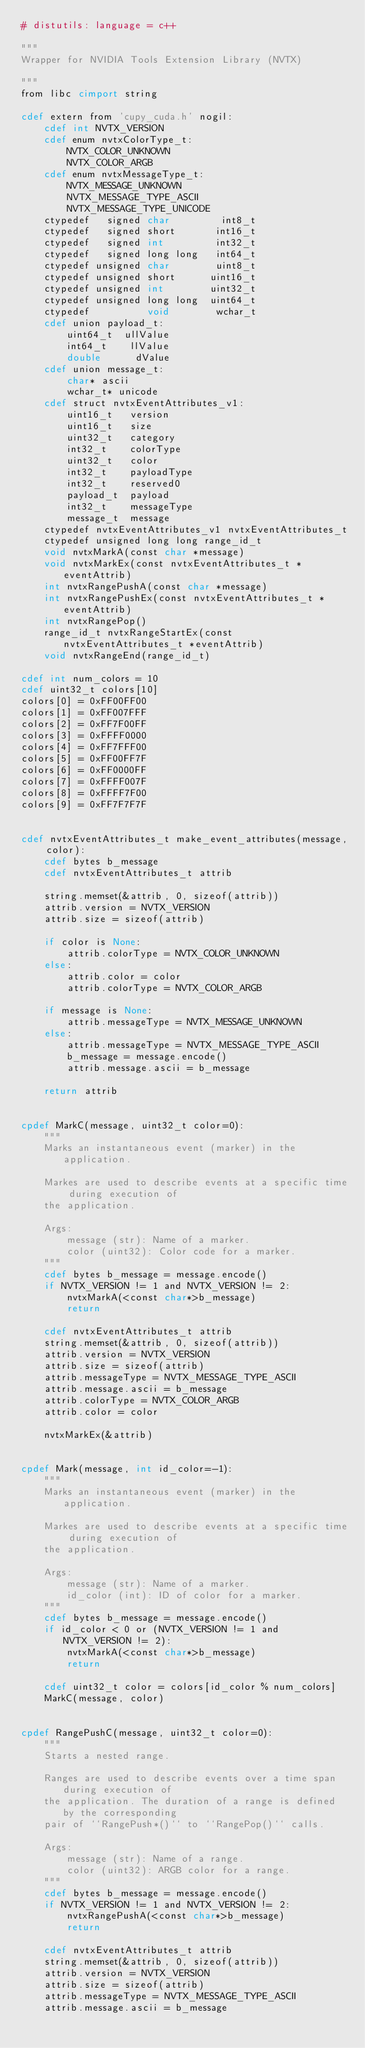<code> <loc_0><loc_0><loc_500><loc_500><_Cython_># distutils: language = c++

"""
Wrapper for NVIDIA Tools Extension Library (NVTX)

"""
from libc cimport string

cdef extern from 'cupy_cuda.h' nogil:
    cdef int NVTX_VERSION
    cdef enum nvtxColorType_t:
        NVTX_COLOR_UNKNOWN
        NVTX_COLOR_ARGB
    cdef enum nvtxMessageType_t:
        NVTX_MESSAGE_UNKNOWN
        NVTX_MESSAGE_TYPE_ASCII
        NVTX_MESSAGE_TYPE_UNICODE
    ctypedef   signed char         int8_t
    ctypedef   signed short       int16_t
    ctypedef   signed int         int32_t
    ctypedef   signed long long   int64_t
    ctypedef unsigned char        uint8_t
    ctypedef unsigned short      uint16_t
    ctypedef unsigned int        uint32_t
    ctypedef unsigned long long  uint64_t
    ctypedef          void        wchar_t
    cdef union payload_t:
        uint64_t  ullValue
        int64_t    llValue
        double      dValue
    cdef union message_t:
        char* ascii
        wchar_t* unicode
    cdef struct nvtxEventAttributes_v1:
        uint16_t   version
        uint16_t   size
        uint32_t   category
        int32_t    colorType
        uint32_t   color
        int32_t    payloadType
        int32_t    reserved0
        payload_t  payload
        int32_t    messageType
        message_t  message
    ctypedef nvtxEventAttributes_v1 nvtxEventAttributes_t
    ctypedef unsigned long long range_id_t
    void nvtxMarkA(const char *message)
    void nvtxMarkEx(const nvtxEventAttributes_t *eventAttrib)
    int nvtxRangePushA(const char *message)
    int nvtxRangePushEx(const nvtxEventAttributes_t *eventAttrib)
    int nvtxRangePop()
    range_id_t nvtxRangeStartEx(const nvtxEventAttributes_t *eventAttrib)
    void nvtxRangeEnd(range_id_t)

cdef int num_colors = 10
cdef uint32_t colors[10]
colors[0] = 0xFF00FF00
colors[1] = 0xFF007FFF
colors[2] = 0xFF7F00FF
colors[3] = 0xFFFF0000
colors[4] = 0xFF7FFF00
colors[5] = 0xFF00FF7F
colors[6] = 0xFF0000FF
colors[7] = 0xFFFF007F
colors[8] = 0xFFFF7F00
colors[9] = 0xFF7F7F7F


cdef nvtxEventAttributes_t make_event_attributes(message, color):
    cdef bytes b_message
    cdef nvtxEventAttributes_t attrib

    string.memset(&attrib, 0, sizeof(attrib))
    attrib.version = NVTX_VERSION
    attrib.size = sizeof(attrib)

    if color is None:
        attrib.colorType = NVTX_COLOR_UNKNOWN
    else:
        attrib.color = color
        attrib.colorType = NVTX_COLOR_ARGB

    if message is None:
        attrib.messageType = NVTX_MESSAGE_UNKNOWN
    else:
        attrib.messageType = NVTX_MESSAGE_TYPE_ASCII
        b_message = message.encode()
        attrib.message.ascii = b_message

    return attrib


cpdef MarkC(message, uint32_t color=0):
    """
    Marks an instantaneous event (marker) in the application.

    Markes are used to describe events at a specific time during execution of
    the application.

    Args:
        message (str): Name of a marker.
        color (uint32): Color code for a marker.
    """
    cdef bytes b_message = message.encode()
    if NVTX_VERSION != 1 and NVTX_VERSION != 2:
        nvtxMarkA(<const char*>b_message)
        return

    cdef nvtxEventAttributes_t attrib
    string.memset(&attrib, 0, sizeof(attrib))
    attrib.version = NVTX_VERSION
    attrib.size = sizeof(attrib)
    attrib.messageType = NVTX_MESSAGE_TYPE_ASCII
    attrib.message.ascii = b_message
    attrib.colorType = NVTX_COLOR_ARGB
    attrib.color = color

    nvtxMarkEx(&attrib)


cpdef Mark(message, int id_color=-1):
    """
    Marks an instantaneous event (marker) in the application.

    Markes are used to describe events at a specific time during execution of
    the application.

    Args:
        message (str): Name of a marker.
        id_color (int): ID of color for a marker.
    """
    cdef bytes b_message = message.encode()
    if id_color < 0 or (NVTX_VERSION != 1 and NVTX_VERSION != 2):
        nvtxMarkA(<const char*>b_message)
        return

    cdef uint32_t color = colors[id_color % num_colors]
    MarkC(message, color)


cpdef RangePushC(message, uint32_t color=0):
    """
    Starts a nested range.

    Ranges are used to describe events over a time span during execution of
    the application. The duration of a range is defined by the corresponding
    pair of ``RangePush*()`` to ``RangePop()`` calls.

    Args:
        message (str): Name of a range.
        color (uint32): ARGB color for a range.
    """
    cdef bytes b_message = message.encode()
    if NVTX_VERSION != 1 and NVTX_VERSION != 2:
        nvtxRangePushA(<const char*>b_message)
        return

    cdef nvtxEventAttributes_t attrib
    string.memset(&attrib, 0, sizeof(attrib))
    attrib.version = NVTX_VERSION
    attrib.size = sizeof(attrib)
    attrib.messageType = NVTX_MESSAGE_TYPE_ASCII
    attrib.message.ascii = b_message</code> 